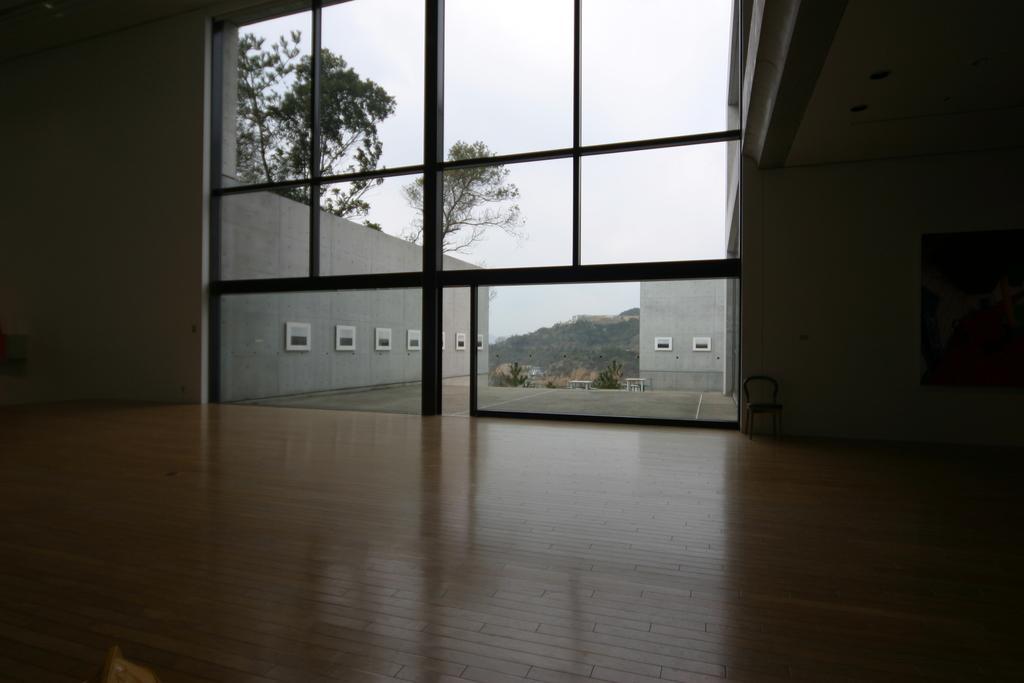Please provide a concise description of this image. This image is taken from inside the building, there is a glass door, beside the door there is a chair. From the glass door, we can see the outside view of trees, mountains and a sky. 